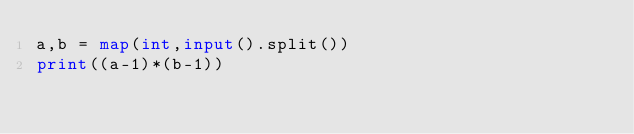Convert code to text. <code><loc_0><loc_0><loc_500><loc_500><_Python_>a,b = map(int,input().split())
print((a-1)*(b-1))</code> 